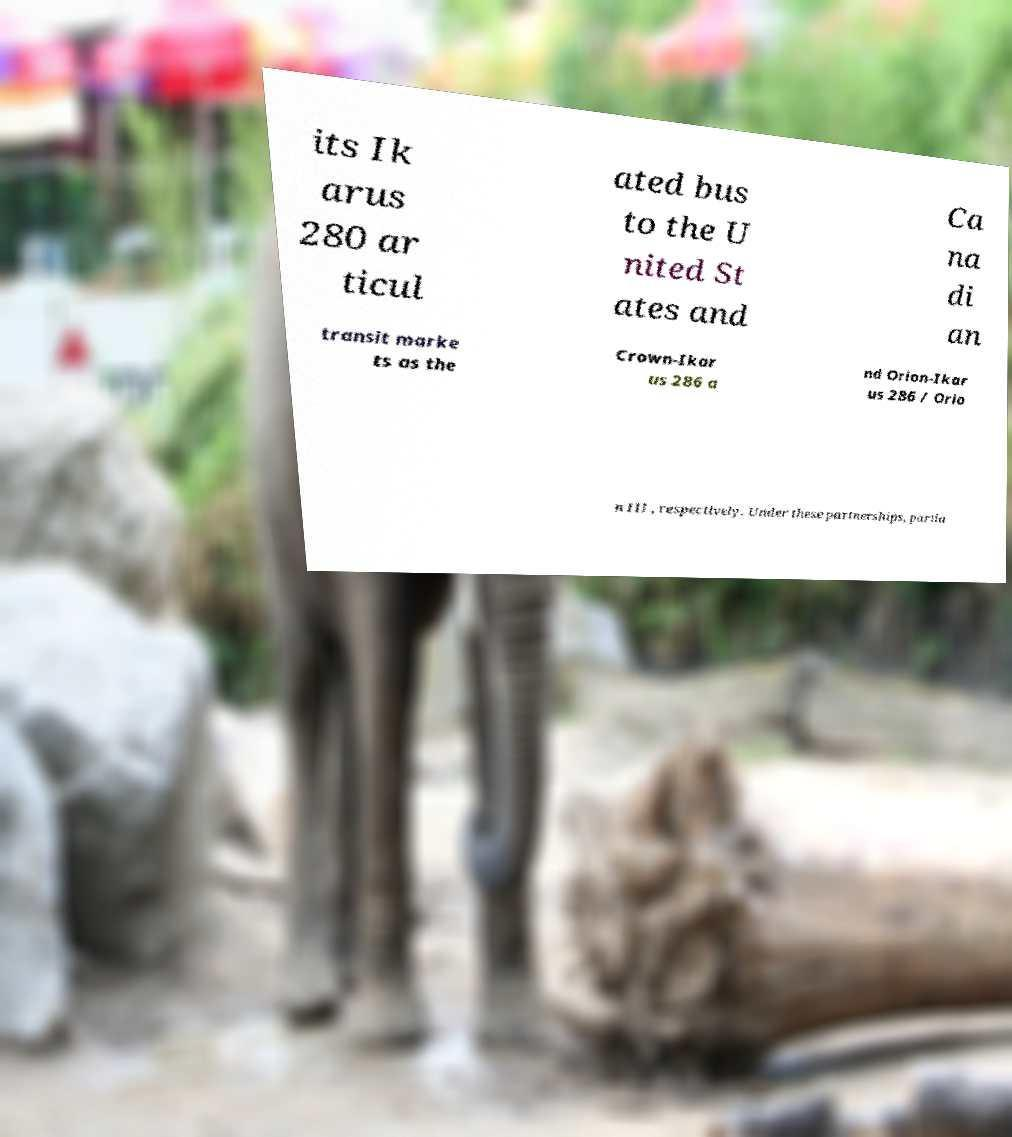Please read and relay the text visible in this image. What does it say? its Ik arus 280 ar ticul ated bus to the U nited St ates and Ca na di an transit marke ts as the Crown-Ikar us 286 a nd Orion-Ikar us 286 / Orio n III , respectively. Under these partnerships, partia 